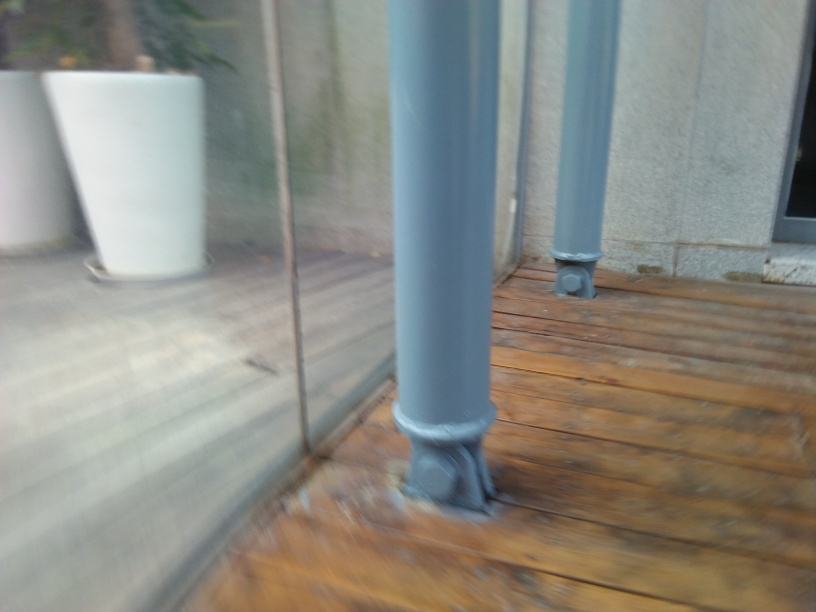What is the atmosphere or mood conveyed by this image? The image seems to convey a tranquil and unassuming mood. The blurriness adds an element of motion or haste, contrasting with what might otherwise be a peaceful setting. It suggests a fleeting moment captured inadvertently. 